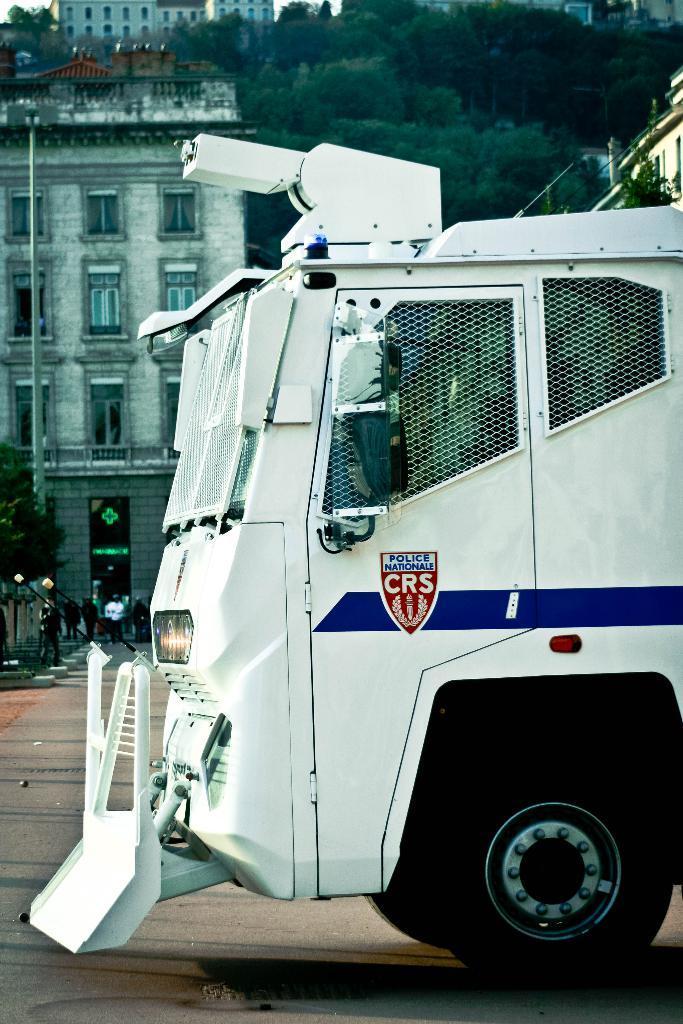Please provide a concise description of this image. In this picture I can see there is a white color truck and it has grills attached to the window and there is a door. In the backdrop there is a building and it has a door and windows. There are trees and there is a mountain in the backdrop. The sky is clear. 